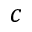<formula> <loc_0><loc_0><loc_500><loc_500>c</formula> 